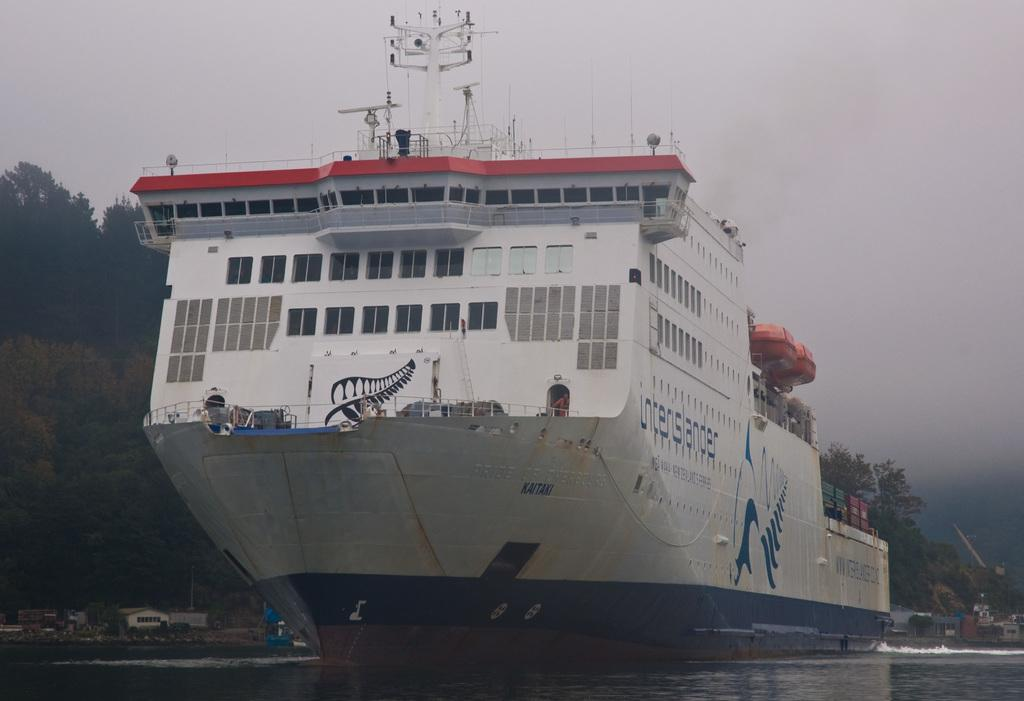What is the main subject in the center of the image? There is a ship in the center of the image. Where is the ship located? The ship is on the water. What can be seen in the background of the image? There are trees and the sky visible in the background of the image. What type of seed is being planted on the slope in the image? There is no seed or slope present in the image; it features a ship on the water with trees and the sky in the background. 